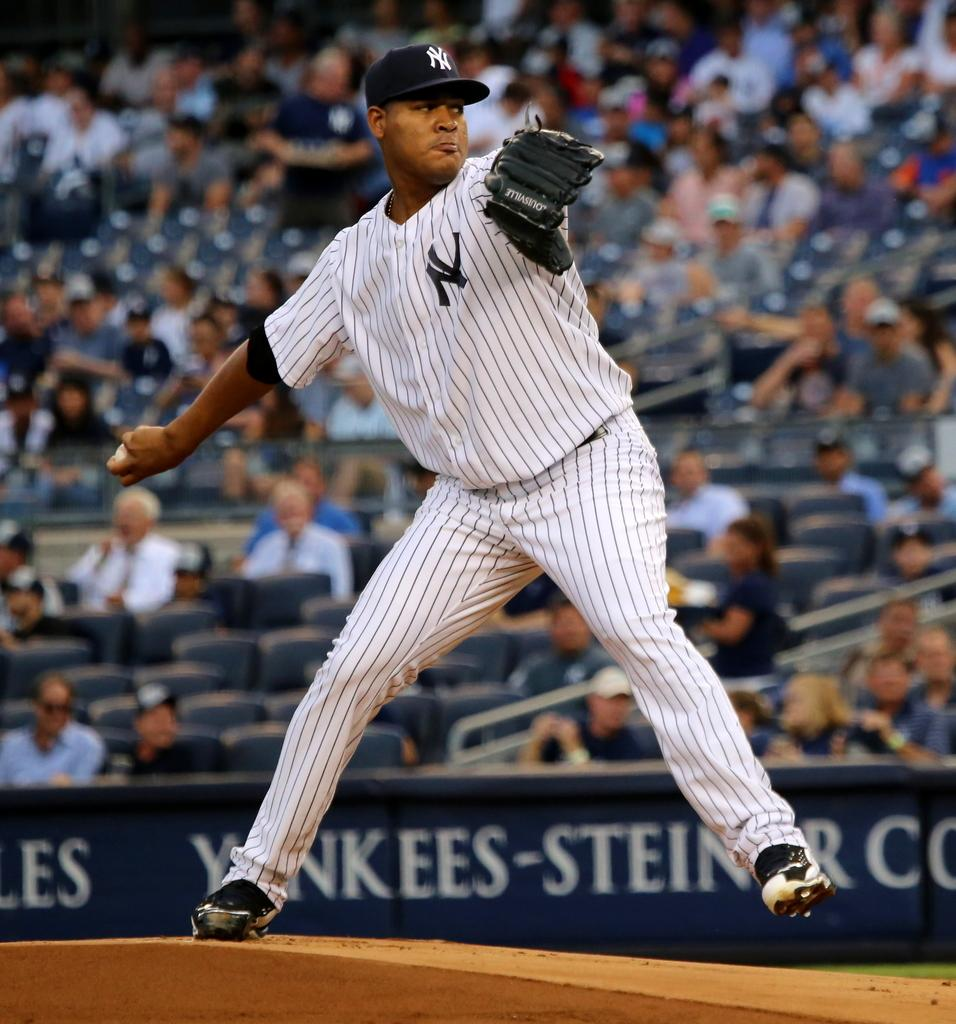<image>
Summarize the visual content of the image. pitcher with ny on jersey and cap getting ready to throw baseball 